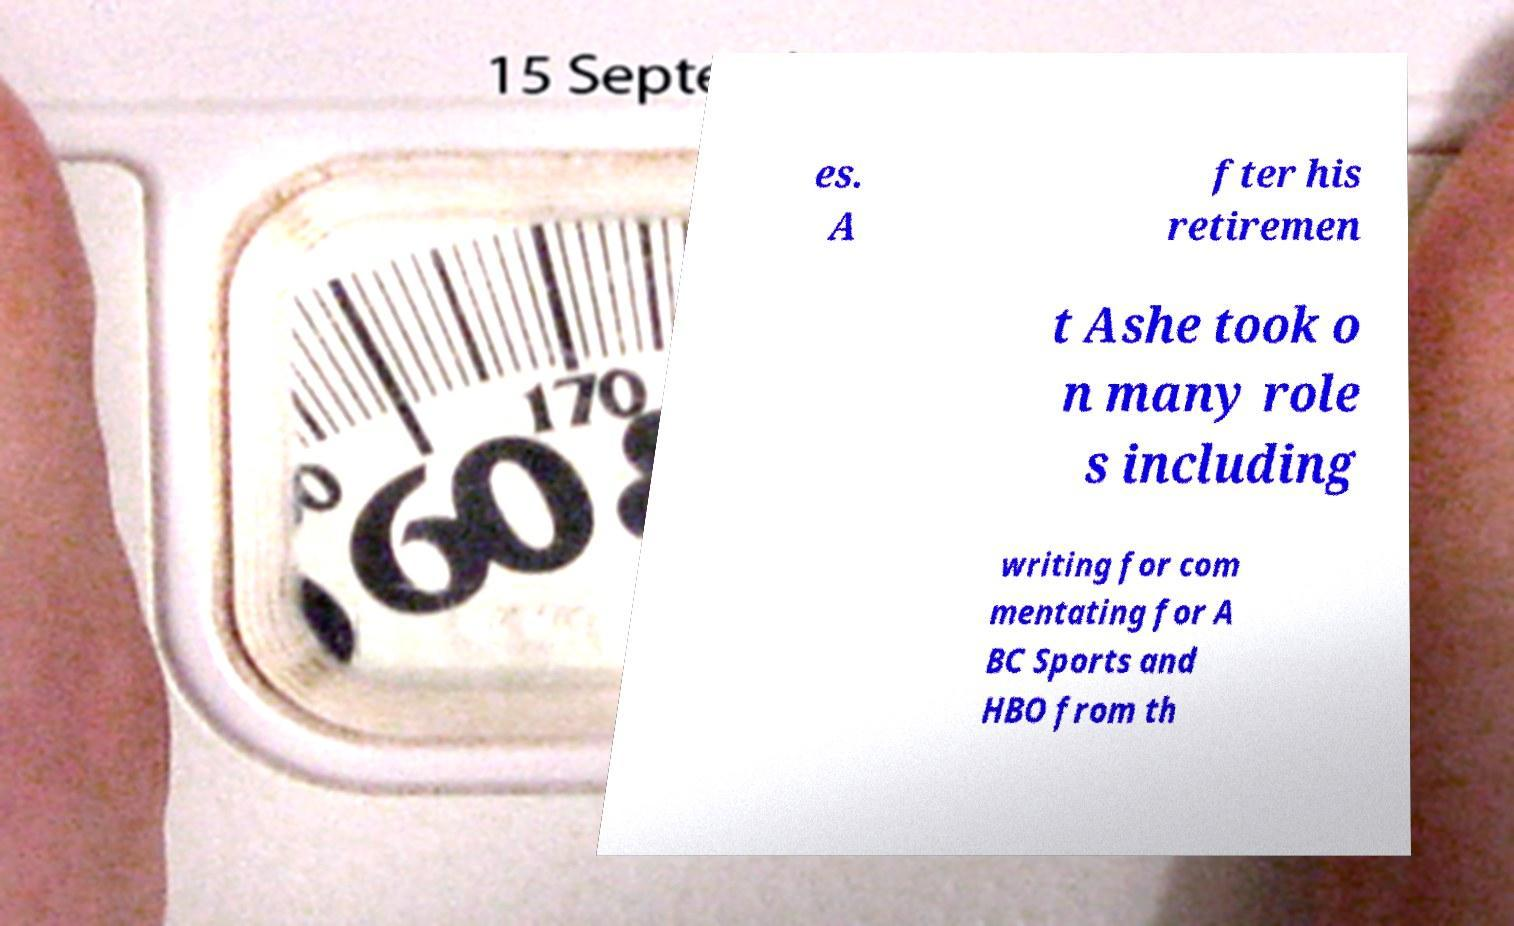Please identify and transcribe the text found in this image. es. A fter his retiremen t Ashe took o n many role s including writing for com mentating for A BC Sports and HBO from th 